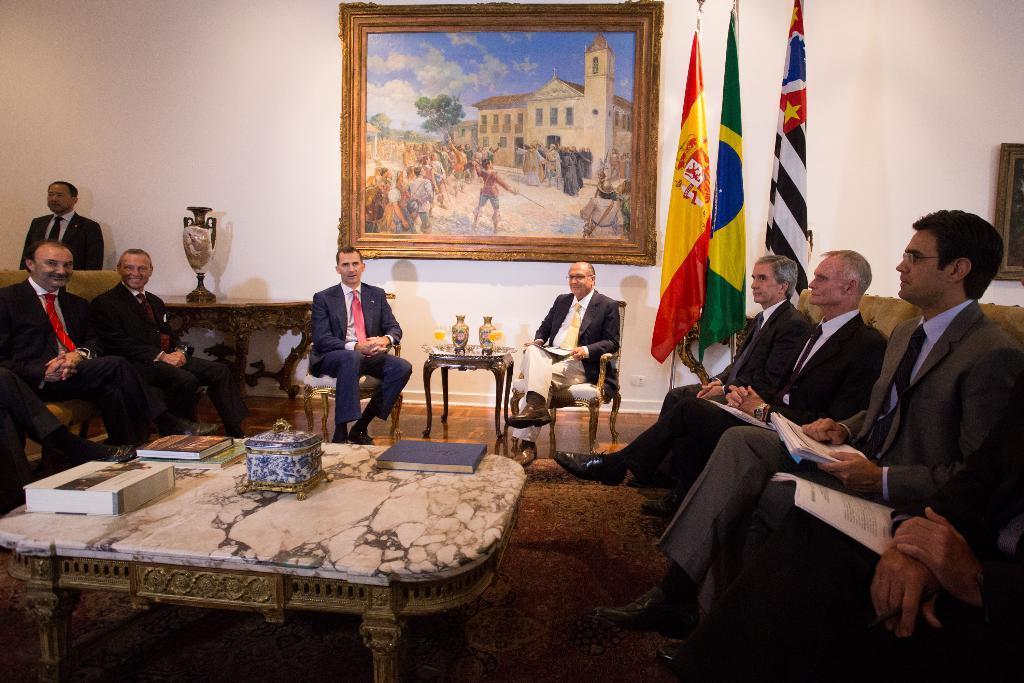Describe this image in one or two sentences. It is a conference room, people are sitting on the chairs, some of them are holding some papers in hands , in front of them in the middle there is a table there is a box on the table, in the background there are three flags, beside it there is a photo frame to the wall and there is also a cream color wall. 